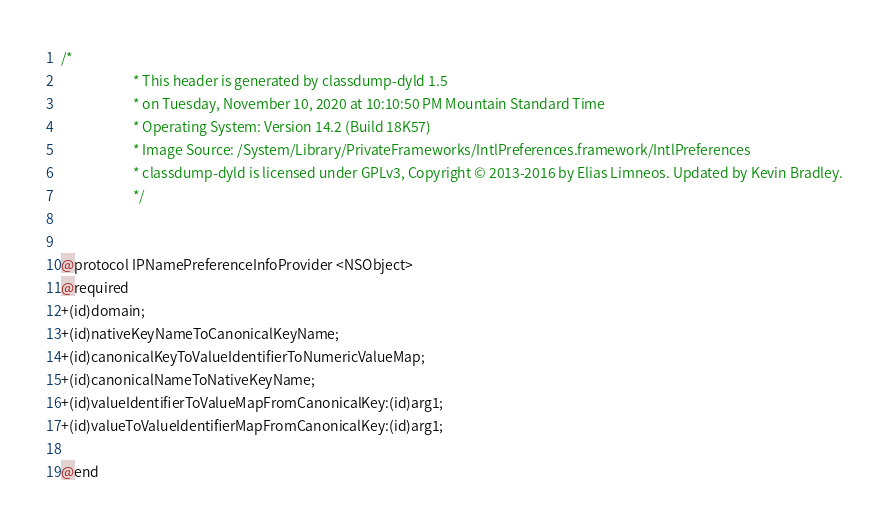Convert code to text. <code><loc_0><loc_0><loc_500><loc_500><_C_>/*
                       * This header is generated by classdump-dyld 1.5
                       * on Tuesday, November 10, 2020 at 10:10:50 PM Mountain Standard Time
                       * Operating System: Version 14.2 (Build 18K57)
                       * Image Source: /System/Library/PrivateFrameworks/IntlPreferences.framework/IntlPreferences
                       * classdump-dyld is licensed under GPLv3, Copyright © 2013-2016 by Elias Limneos. Updated by Kevin Bradley.
                       */


@protocol IPNamePreferenceInfoProvider <NSObject>
@required
+(id)domain;
+(id)nativeKeyNameToCanonicalKeyName;
+(id)canonicalKeyToValueIdentifierToNumericValueMap;
+(id)canonicalNameToNativeKeyName;
+(id)valueIdentifierToValueMapFromCanonicalKey:(id)arg1;
+(id)valueToValueIdentifierMapFromCanonicalKey:(id)arg1;

@end

</code> 